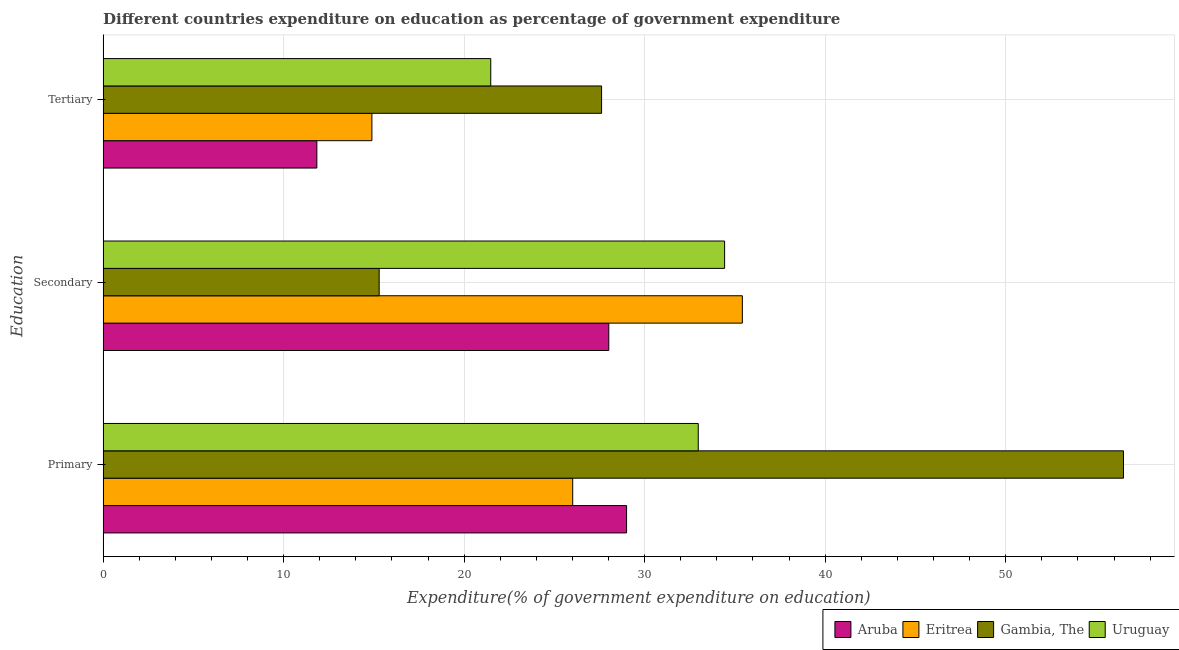How many different coloured bars are there?
Your response must be concise. 4. How many groups of bars are there?
Provide a short and direct response. 3. Are the number of bars per tick equal to the number of legend labels?
Keep it short and to the point. Yes. How many bars are there on the 1st tick from the bottom?
Provide a short and direct response. 4. What is the label of the 2nd group of bars from the top?
Offer a terse response. Secondary. What is the expenditure on secondary education in Gambia, The?
Provide a succinct answer. 15.29. Across all countries, what is the maximum expenditure on secondary education?
Ensure brevity in your answer.  35.41. Across all countries, what is the minimum expenditure on primary education?
Ensure brevity in your answer.  26.01. In which country was the expenditure on primary education maximum?
Make the answer very short. Gambia, The. In which country was the expenditure on secondary education minimum?
Offer a terse response. Gambia, The. What is the total expenditure on primary education in the graph?
Provide a short and direct response. 144.51. What is the difference between the expenditure on primary education in Aruba and that in Gambia, The?
Your answer should be very brief. -27.53. What is the difference between the expenditure on tertiary education in Gambia, The and the expenditure on secondary education in Aruba?
Provide a short and direct response. -0.4. What is the average expenditure on primary education per country?
Provide a succinct answer. 36.13. What is the difference between the expenditure on secondary education and expenditure on tertiary education in Gambia, The?
Offer a very short reply. -12.32. In how many countries, is the expenditure on tertiary education greater than 54 %?
Your answer should be very brief. 0. What is the ratio of the expenditure on secondary education in Gambia, The to that in Aruba?
Offer a terse response. 0.55. Is the expenditure on secondary education in Eritrea less than that in Uruguay?
Provide a succinct answer. No. What is the difference between the highest and the second highest expenditure on primary education?
Keep it short and to the point. 23.56. What is the difference between the highest and the lowest expenditure on tertiary education?
Keep it short and to the point. 15.77. What does the 1st bar from the top in Primary represents?
Keep it short and to the point. Uruguay. What does the 1st bar from the bottom in Primary represents?
Offer a very short reply. Aruba. Is it the case that in every country, the sum of the expenditure on primary education and expenditure on secondary education is greater than the expenditure on tertiary education?
Provide a short and direct response. Yes. How many bars are there?
Offer a very short reply. 12. How many countries are there in the graph?
Your response must be concise. 4. Where does the legend appear in the graph?
Ensure brevity in your answer.  Bottom right. How are the legend labels stacked?
Give a very brief answer. Horizontal. What is the title of the graph?
Give a very brief answer. Different countries expenditure on education as percentage of government expenditure. What is the label or title of the X-axis?
Provide a succinct answer. Expenditure(% of government expenditure on education). What is the label or title of the Y-axis?
Make the answer very short. Education. What is the Expenditure(% of government expenditure on education) in Aruba in Primary?
Give a very brief answer. 29. What is the Expenditure(% of government expenditure on education) of Eritrea in Primary?
Your answer should be very brief. 26.01. What is the Expenditure(% of government expenditure on education) in Gambia, The in Primary?
Your answer should be very brief. 56.53. What is the Expenditure(% of government expenditure on education) of Uruguay in Primary?
Provide a short and direct response. 32.97. What is the Expenditure(% of government expenditure on education) in Aruba in Secondary?
Offer a terse response. 28.01. What is the Expenditure(% of government expenditure on education) of Eritrea in Secondary?
Keep it short and to the point. 35.41. What is the Expenditure(% of government expenditure on education) in Gambia, The in Secondary?
Your answer should be very brief. 15.29. What is the Expenditure(% of government expenditure on education) in Uruguay in Secondary?
Give a very brief answer. 34.43. What is the Expenditure(% of government expenditure on education) of Aruba in Tertiary?
Offer a very short reply. 11.84. What is the Expenditure(% of government expenditure on education) in Eritrea in Tertiary?
Offer a terse response. 14.89. What is the Expenditure(% of government expenditure on education) of Gambia, The in Tertiary?
Offer a terse response. 27.61. What is the Expenditure(% of government expenditure on education) of Uruguay in Tertiary?
Offer a very short reply. 21.47. Across all Education, what is the maximum Expenditure(% of government expenditure on education) of Aruba?
Offer a very short reply. 29. Across all Education, what is the maximum Expenditure(% of government expenditure on education) of Eritrea?
Your answer should be compact. 35.41. Across all Education, what is the maximum Expenditure(% of government expenditure on education) in Gambia, The?
Offer a very short reply. 56.53. Across all Education, what is the maximum Expenditure(% of government expenditure on education) in Uruguay?
Your response must be concise. 34.43. Across all Education, what is the minimum Expenditure(% of government expenditure on education) of Aruba?
Your answer should be very brief. 11.84. Across all Education, what is the minimum Expenditure(% of government expenditure on education) of Eritrea?
Your answer should be compact. 14.89. Across all Education, what is the minimum Expenditure(% of government expenditure on education) of Gambia, The?
Offer a terse response. 15.29. Across all Education, what is the minimum Expenditure(% of government expenditure on education) of Uruguay?
Make the answer very short. 21.47. What is the total Expenditure(% of government expenditure on education) of Aruba in the graph?
Provide a succinct answer. 68.85. What is the total Expenditure(% of government expenditure on education) in Eritrea in the graph?
Ensure brevity in your answer.  76.31. What is the total Expenditure(% of government expenditure on education) of Gambia, The in the graph?
Your answer should be very brief. 99.43. What is the total Expenditure(% of government expenditure on education) in Uruguay in the graph?
Make the answer very short. 88.87. What is the difference between the Expenditure(% of government expenditure on education) in Aruba in Primary and that in Secondary?
Give a very brief answer. 0.99. What is the difference between the Expenditure(% of government expenditure on education) of Eritrea in Primary and that in Secondary?
Keep it short and to the point. -9.4. What is the difference between the Expenditure(% of government expenditure on education) of Gambia, The in Primary and that in Secondary?
Ensure brevity in your answer.  41.23. What is the difference between the Expenditure(% of government expenditure on education) of Uruguay in Primary and that in Secondary?
Your response must be concise. -1.46. What is the difference between the Expenditure(% of government expenditure on education) of Aruba in Primary and that in Tertiary?
Provide a short and direct response. 17.16. What is the difference between the Expenditure(% of government expenditure on education) of Eritrea in Primary and that in Tertiary?
Offer a terse response. 11.12. What is the difference between the Expenditure(% of government expenditure on education) of Gambia, The in Primary and that in Tertiary?
Offer a very short reply. 28.91. What is the difference between the Expenditure(% of government expenditure on education) of Uruguay in Primary and that in Tertiary?
Your answer should be very brief. 11.5. What is the difference between the Expenditure(% of government expenditure on education) in Aruba in Secondary and that in Tertiary?
Your answer should be compact. 16.17. What is the difference between the Expenditure(% of government expenditure on education) of Eritrea in Secondary and that in Tertiary?
Your answer should be very brief. 20.52. What is the difference between the Expenditure(% of government expenditure on education) of Gambia, The in Secondary and that in Tertiary?
Give a very brief answer. -12.32. What is the difference between the Expenditure(% of government expenditure on education) in Uruguay in Secondary and that in Tertiary?
Make the answer very short. 12.96. What is the difference between the Expenditure(% of government expenditure on education) in Aruba in Primary and the Expenditure(% of government expenditure on education) in Eritrea in Secondary?
Ensure brevity in your answer.  -6.41. What is the difference between the Expenditure(% of government expenditure on education) of Aruba in Primary and the Expenditure(% of government expenditure on education) of Gambia, The in Secondary?
Provide a succinct answer. 13.71. What is the difference between the Expenditure(% of government expenditure on education) of Aruba in Primary and the Expenditure(% of government expenditure on education) of Uruguay in Secondary?
Offer a very short reply. -5.43. What is the difference between the Expenditure(% of government expenditure on education) in Eritrea in Primary and the Expenditure(% of government expenditure on education) in Gambia, The in Secondary?
Provide a succinct answer. 10.72. What is the difference between the Expenditure(% of government expenditure on education) in Eritrea in Primary and the Expenditure(% of government expenditure on education) in Uruguay in Secondary?
Your answer should be very brief. -8.42. What is the difference between the Expenditure(% of government expenditure on education) in Gambia, The in Primary and the Expenditure(% of government expenditure on education) in Uruguay in Secondary?
Offer a very short reply. 22.1. What is the difference between the Expenditure(% of government expenditure on education) in Aruba in Primary and the Expenditure(% of government expenditure on education) in Eritrea in Tertiary?
Make the answer very short. 14.11. What is the difference between the Expenditure(% of government expenditure on education) in Aruba in Primary and the Expenditure(% of government expenditure on education) in Gambia, The in Tertiary?
Offer a very short reply. 1.38. What is the difference between the Expenditure(% of government expenditure on education) of Aruba in Primary and the Expenditure(% of government expenditure on education) of Uruguay in Tertiary?
Your answer should be compact. 7.52. What is the difference between the Expenditure(% of government expenditure on education) of Eritrea in Primary and the Expenditure(% of government expenditure on education) of Gambia, The in Tertiary?
Your answer should be very brief. -1.6. What is the difference between the Expenditure(% of government expenditure on education) of Eritrea in Primary and the Expenditure(% of government expenditure on education) of Uruguay in Tertiary?
Offer a very short reply. 4.54. What is the difference between the Expenditure(% of government expenditure on education) of Gambia, The in Primary and the Expenditure(% of government expenditure on education) of Uruguay in Tertiary?
Offer a terse response. 35.05. What is the difference between the Expenditure(% of government expenditure on education) of Aruba in Secondary and the Expenditure(% of government expenditure on education) of Eritrea in Tertiary?
Your answer should be compact. 13.12. What is the difference between the Expenditure(% of government expenditure on education) in Aruba in Secondary and the Expenditure(% of government expenditure on education) in Gambia, The in Tertiary?
Offer a very short reply. 0.4. What is the difference between the Expenditure(% of government expenditure on education) in Aruba in Secondary and the Expenditure(% of government expenditure on education) in Uruguay in Tertiary?
Ensure brevity in your answer.  6.54. What is the difference between the Expenditure(% of government expenditure on education) of Eritrea in Secondary and the Expenditure(% of government expenditure on education) of Gambia, The in Tertiary?
Your response must be concise. 7.8. What is the difference between the Expenditure(% of government expenditure on education) of Eritrea in Secondary and the Expenditure(% of government expenditure on education) of Uruguay in Tertiary?
Your answer should be very brief. 13.94. What is the difference between the Expenditure(% of government expenditure on education) in Gambia, The in Secondary and the Expenditure(% of government expenditure on education) in Uruguay in Tertiary?
Give a very brief answer. -6.18. What is the average Expenditure(% of government expenditure on education) in Aruba per Education?
Give a very brief answer. 22.95. What is the average Expenditure(% of government expenditure on education) in Eritrea per Education?
Your answer should be very brief. 25.44. What is the average Expenditure(% of government expenditure on education) of Gambia, The per Education?
Provide a short and direct response. 33.14. What is the average Expenditure(% of government expenditure on education) in Uruguay per Education?
Your answer should be very brief. 29.62. What is the difference between the Expenditure(% of government expenditure on education) of Aruba and Expenditure(% of government expenditure on education) of Eritrea in Primary?
Your response must be concise. 2.99. What is the difference between the Expenditure(% of government expenditure on education) of Aruba and Expenditure(% of government expenditure on education) of Gambia, The in Primary?
Ensure brevity in your answer.  -27.53. What is the difference between the Expenditure(% of government expenditure on education) of Aruba and Expenditure(% of government expenditure on education) of Uruguay in Primary?
Your answer should be very brief. -3.97. What is the difference between the Expenditure(% of government expenditure on education) of Eritrea and Expenditure(% of government expenditure on education) of Gambia, The in Primary?
Offer a very short reply. -30.51. What is the difference between the Expenditure(% of government expenditure on education) in Eritrea and Expenditure(% of government expenditure on education) in Uruguay in Primary?
Your response must be concise. -6.96. What is the difference between the Expenditure(% of government expenditure on education) of Gambia, The and Expenditure(% of government expenditure on education) of Uruguay in Primary?
Make the answer very short. 23.56. What is the difference between the Expenditure(% of government expenditure on education) in Aruba and Expenditure(% of government expenditure on education) in Eritrea in Secondary?
Offer a terse response. -7.4. What is the difference between the Expenditure(% of government expenditure on education) in Aruba and Expenditure(% of government expenditure on education) in Gambia, The in Secondary?
Keep it short and to the point. 12.72. What is the difference between the Expenditure(% of government expenditure on education) in Aruba and Expenditure(% of government expenditure on education) in Uruguay in Secondary?
Keep it short and to the point. -6.42. What is the difference between the Expenditure(% of government expenditure on education) in Eritrea and Expenditure(% of government expenditure on education) in Gambia, The in Secondary?
Provide a succinct answer. 20.12. What is the difference between the Expenditure(% of government expenditure on education) in Eritrea and Expenditure(% of government expenditure on education) in Uruguay in Secondary?
Offer a terse response. 0.98. What is the difference between the Expenditure(% of government expenditure on education) of Gambia, The and Expenditure(% of government expenditure on education) of Uruguay in Secondary?
Provide a short and direct response. -19.14. What is the difference between the Expenditure(% of government expenditure on education) in Aruba and Expenditure(% of government expenditure on education) in Eritrea in Tertiary?
Offer a very short reply. -3.05. What is the difference between the Expenditure(% of government expenditure on education) of Aruba and Expenditure(% of government expenditure on education) of Gambia, The in Tertiary?
Ensure brevity in your answer.  -15.77. What is the difference between the Expenditure(% of government expenditure on education) in Aruba and Expenditure(% of government expenditure on education) in Uruguay in Tertiary?
Ensure brevity in your answer.  -9.63. What is the difference between the Expenditure(% of government expenditure on education) of Eritrea and Expenditure(% of government expenditure on education) of Gambia, The in Tertiary?
Your response must be concise. -12.72. What is the difference between the Expenditure(% of government expenditure on education) of Eritrea and Expenditure(% of government expenditure on education) of Uruguay in Tertiary?
Offer a very short reply. -6.58. What is the difference between the Expenditure(% of government expenditure on education) in Gambia, The and Expenditure(% of government expenditure on education) in Uruguay in Tertiary?
Give a very brief answer. 6.14. What is the ratio of the Expenditure(% of government expenditure on education) of Aruba in Primary to that in Secondary?
Give a very brief answer. 1.04. What is the ratio of the Expenditure(% of government expenditure on education) of Eritrea in Primary to that in Secondary?
Keep it short and to the point. 0.73. What is the ratio of the Expenditure(% of government expenditure on education) in Gambia, The in Primary to that in Secondary?
Ensure brevity in your answer.  3.7. What is the ratio of the Expenditure(% of government expenditure on education) in Uruguay in Primary to that in Secondary?
Provide a succinct answer. 0.96. What is the ratio of the Expenditure(% of government expenditure on education) of Aruba in Primary to that in Tertiary?
Your response must be concise. 2.45. What is the ratio of the Expenditure(% of government expenditure on education) of Eritrea in Primary to that in Tertiary?
Give a very brief answer. 1.75. What is the ratio of the Expenditure(% of government expenditure on education) of Gambia, The in Primary to that in Tertiary?
Your response must be concise. 2.05. What is the ratio of the Expenditure(% of government expenditure on education) of Uruguay in Primary to that in Tertiary?
Your response must be concise. 1.54. What is the ratio of the Expenditure(% of government expenditure on education) in Aruba in Secondary to that in Tertiary?
Your answer should be compact. 2.37. What is the ratio of the Expenditure(% of government expenditure on education) in Eritrea in Secondary to that in Tertiary?
Provide a succinct answer. 2.38. What is the ratio of the Expenditure(% of government expenditure on education) in Gambia, The in Secondary to that in Tertiary?
Your answer should be very brief. 0.55. What is the ratio of the Expenditure(% of government expenditure on education) in Uruguay in Secondary to that in Tertiary?
Keep it short and to the point. 1.6. What is the difference between the highest and the second highest Expenditure(% of government expenditure on education) in Aruba?
Provide a succinct answer. 0.99. What is the difference between the highest and the second highest Expenditure(% of government expenditure on education) of Eritrea?
Ensure brevity in your answer.  9.4. What is the difference between the highest and the second highest Expenditure(% of government expenditure on education) of Gambia, The?
Offer a very short reply. 28.91. What is the difference between the highest and the second highest Expenditure(% of government expenditure on education) of Uruguay?
Your answer should be compact. 1.46. What is the difference between the highest and the lowest Expenditure(% of government expenditure on education) of Aruba?
Offer a very short reply. 17.16. What is the difference between the highest and the lowest Expenditure(% of government expenditure on education) in Eritrea?
Offer a terse response. 20.52. What is the difference between the highest and the lowest Expenditure(% of government expenditure on education) in Gambia, The?
Give a very brief answer. 41.23. What is the difference between the highest and the lowest Expenditure(% of government expenditure on education) of Uruguay?
Ensure brevity in your answer.  12.96. 